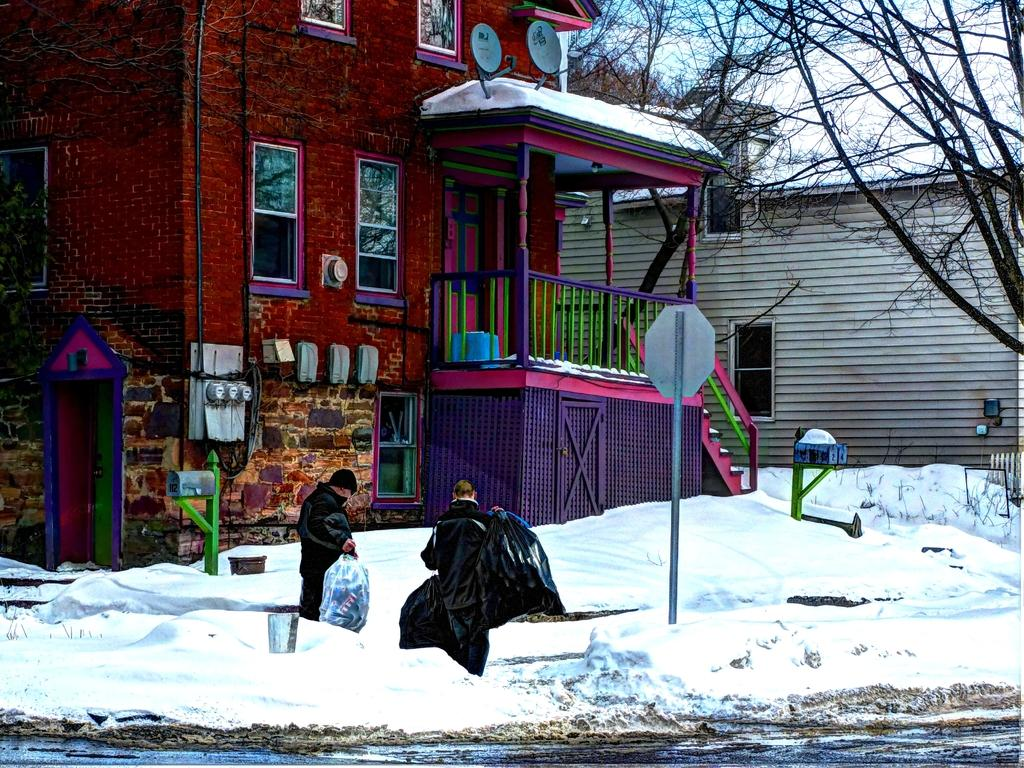How many people are in the image? There are two persons standing in the image. What are the persons holding? The persons are holding bags. What is the weather like in the image? There is snow visible in the image, indicating a cold or wintry environment. What can be seen on the pole in the image? There is a board on a pole in the image. What is visible in the background of the image? There is a wall, windows, and trees in the background of the image. What type of mountain can be seen in the background of the image? There is no mountain visible in the image; only a wall, windows, and trees are present in the background. 